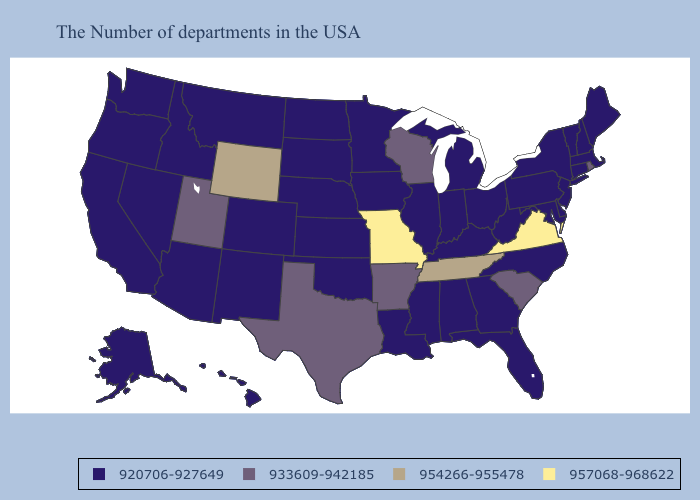Name the states that have a value in the range 954266-955478?
Answer briefly. Tennessee, Wyoming. Among the states that border Utah , does New Mexico have the highest value?
Keep it brief. No. Among the states that border Arizona , which have the highest value?
Answer briefly. Utah. What is the lowest value in the South?
Short answer required. 920706-927649. What is the value of Iowa?
Be succinct. 920706-927649. What is the value of Idaho?
Be succinct. 920706-927649. How many symbols are there in the legend?
Short answer required. 4. Name the states that have a value in the range 954266-955478?
Write a very short answer. Tennessee, Wyoming. Name the states that have a value in the range 954266-955478?
Be succinct. Tennessee, Wyoming. Name the states that have a value in the range 957068-968622?
Short answer required. Virginia, Missouri. Among the states that border Vermont , which have the highest value?
Short answer required. Massachusetts, New Hampshire, New York. How many symbols are there in the legend?
Concise answer only. 4. Name the states that have a value in the range 933609-942185?
Be succinct. Rhode Island, South Carolina, Wisconsin, Arkansas, Texas, Utah. Does Missouri have the highest value in the MidWest?
Quick response, please. Yes. 